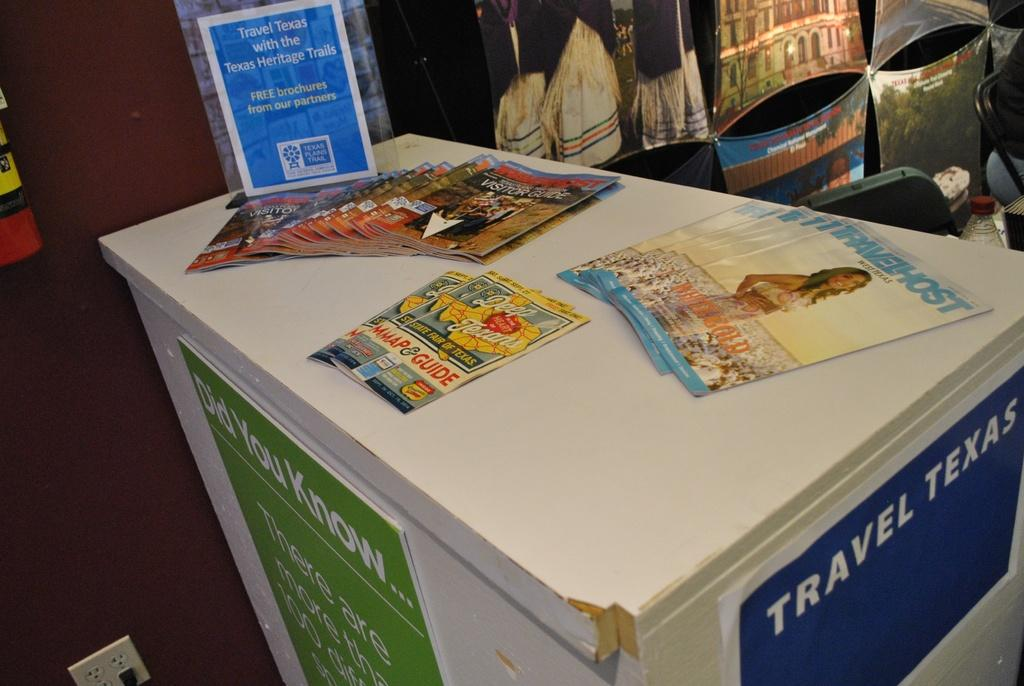<image>
Offer a succinct explanation of the picture presented. A white table has stacks of magazines on it including Travel Host. 